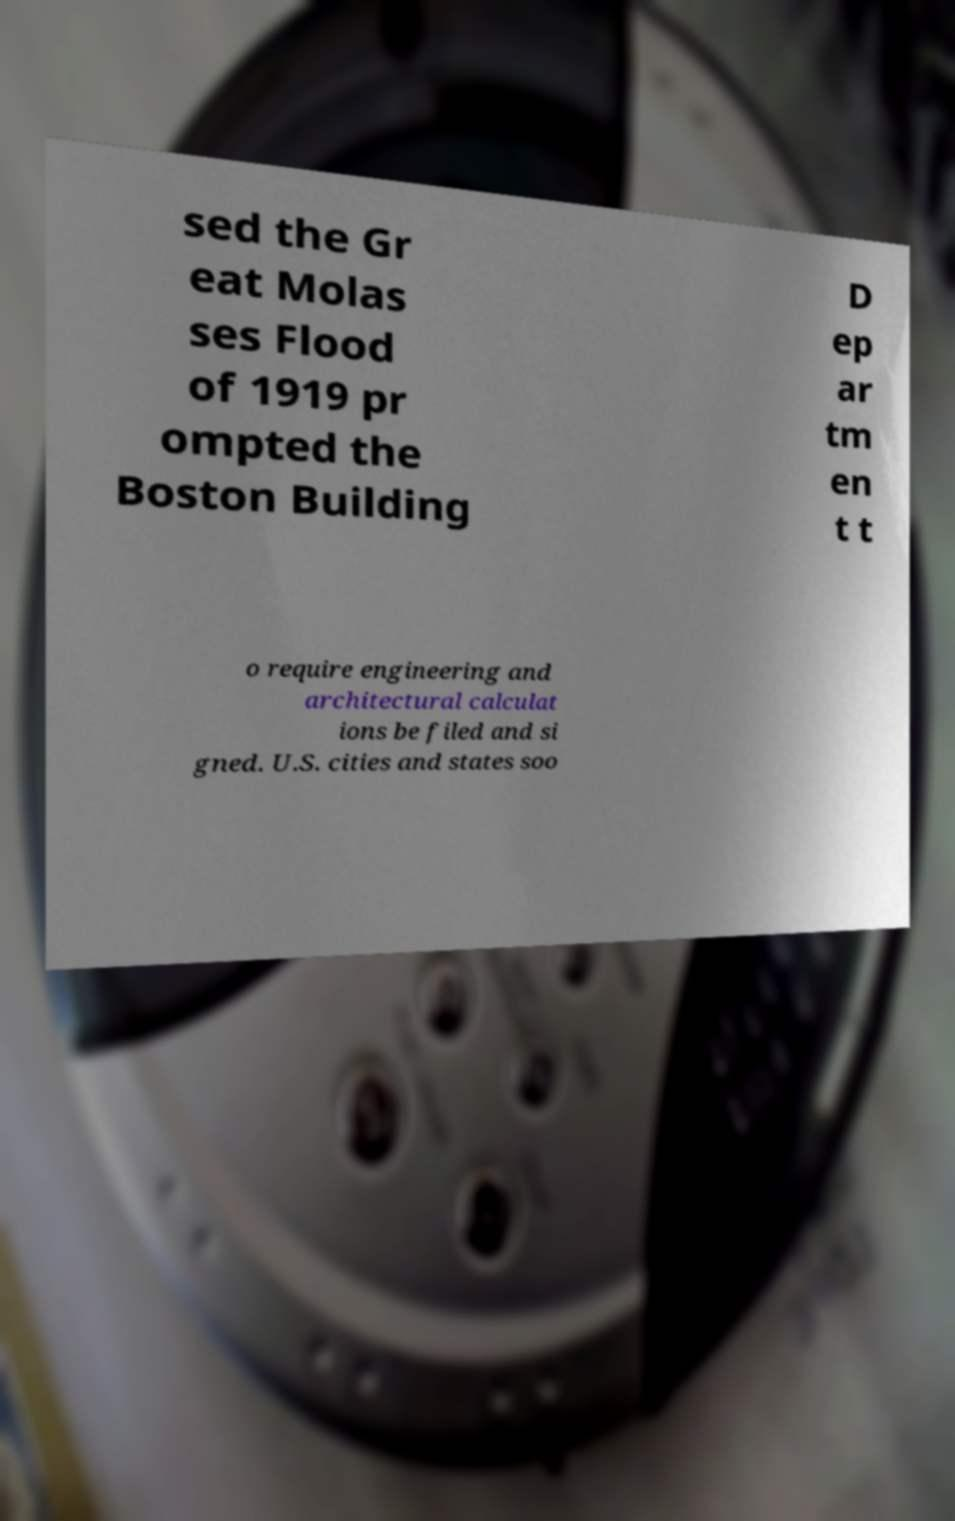I need the written content from this picture converted into text. Can you do that? sed the Gr eat Molas ses Flood of 1919 pr ompted the Boston Building D ep ar tm en t t o require engineering and architectural calculat ions be filed and si gned. U.S. cities and states soo 